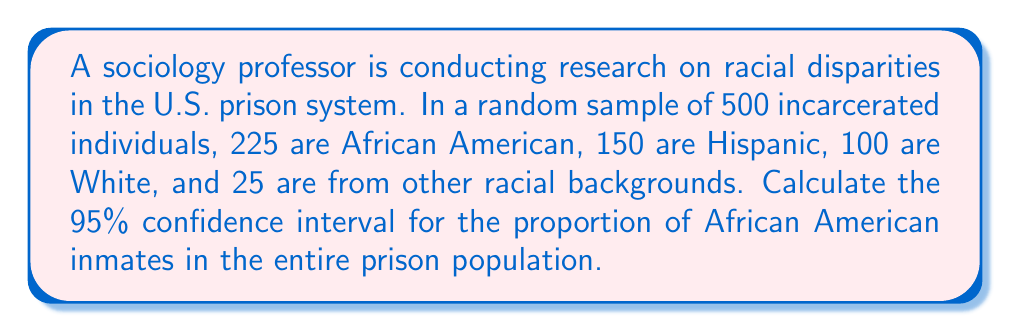Provide a solution to this math problem. To calculate the confidence interval for the proportion of African American inmates, we'll use the following steps:

1. Calculate the sample proportion:
   $\hat{p} = \frac{\text{number of African American inmates}}{\text{total sample size}} = \frac{225}{500} = 0.45$

2. Calculate the standard error:
   $SE = \sqrt{\frac{\hat{p}(1-\hat{p})}{n}} = \sqrt{\frac{0.45(1-0.45)}{500}} = 0.0222$

3. For a 95% confidence interval, use z-score of 1.96 (from standard normal distribution table).

4. Calculate the margin of error:
   $ME = z \cdot SE = 1.96 \cdot 0.0222 = 0.0435$

5. Calculate the confidence interval:
   Lower bound: $\hat{p} - ME = 0.45 - 0.0435 = 0.4065$
   Upper bound: $\hat{p} + ME = 0.45 + 0.0435 = 0.4935$

Therefore, the 95% confidence interval for the proportion of African American inmates in the entire prison population is (0.4065, 0.4935) or (40.65%, 49.35%).

This means we can be 95% confident that the true proportion of African American inmates in the entire prison population falls between 40.65% and 49.35%.
Answer: (0.4065, 0.4935) 